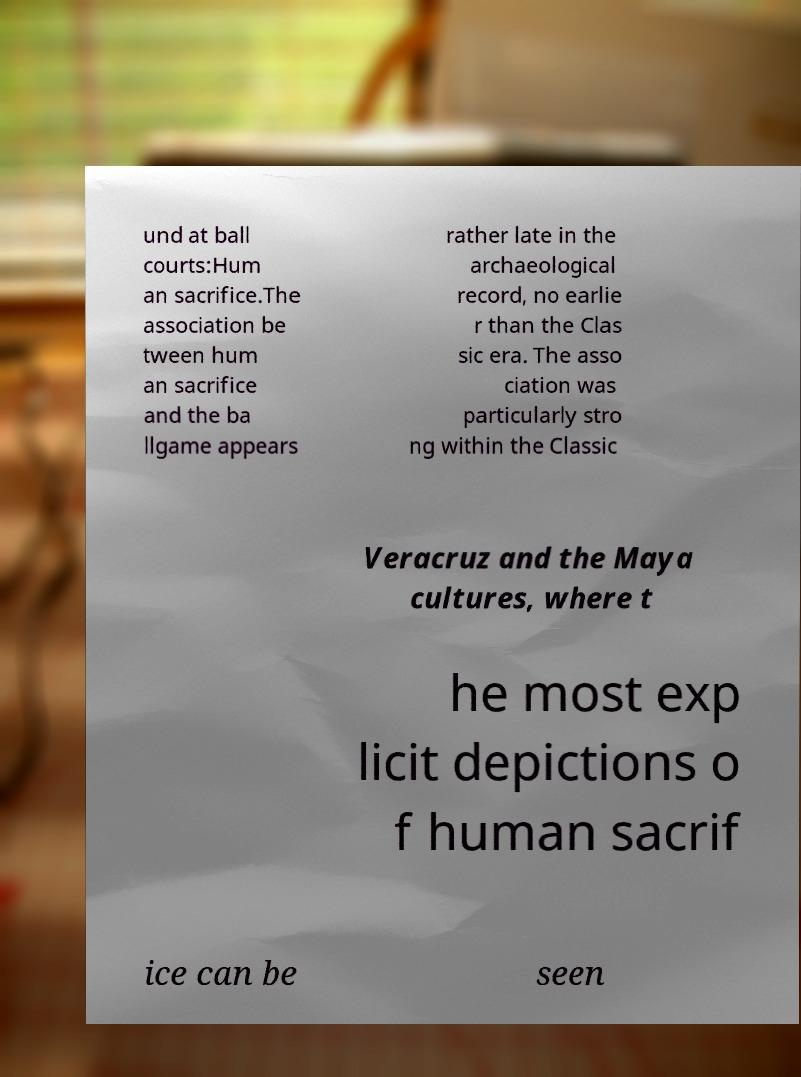I need the written content from this picture converted into text. Can you do that? und at ball courts:Hum an sacrifice.The association be tween hum an sacrifice and the ba llgame appears rather late in the archaeological record, no earlie r than the Clas sic era. The asso ciation was particularly stro ng within the Classic Veracruz and the Maya cultures, where t he most exp licit depictions o f human sacrif ice can be seen 